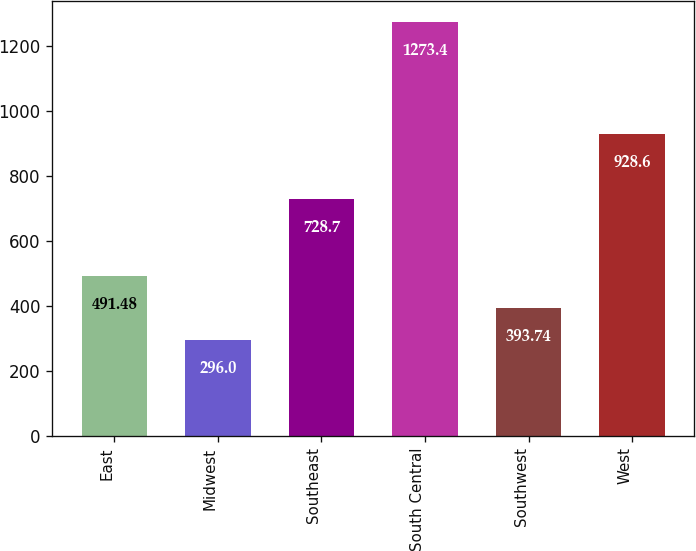Convert chart to OTSL. <chart><loc_0><loc_0><loc_500><loc_500><bar_chart><fcel>East<fcel>Midwest<fcel>Southeast<fcel>South Central<fcel>Southwest<fcel>West<nl><fcel>491.48<fcel>296<fcel>728.7<fcel>1273.4<fcel>393.74<fcel>928.6<nl></chart> 